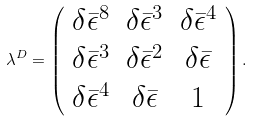<formula> <loc_0><loc_0><loc_500><loc_500>\lambda ^ { D } = \left ( \begin{array} { c c c } { { \delta \bar { \epsilon } ^ { 8 } } } & { { \delta \bar { \epsilon } ^ { 3 } } } & { { \delta \bar { \epsilon } ^ { 4 } } } \\ { { \delta \bar { \epsilon } ^ { 3 } } } & { { \delta \bar { \epsilon } ^ { 2 } } } & { { \delta \bar { \epsilon } } } \\ { { \delta \bar { \epsilon } ^ { 4 } } } & { { \delta \bar { \epsilon } } } & { 1 } \end{array} \right ) .</formula> 